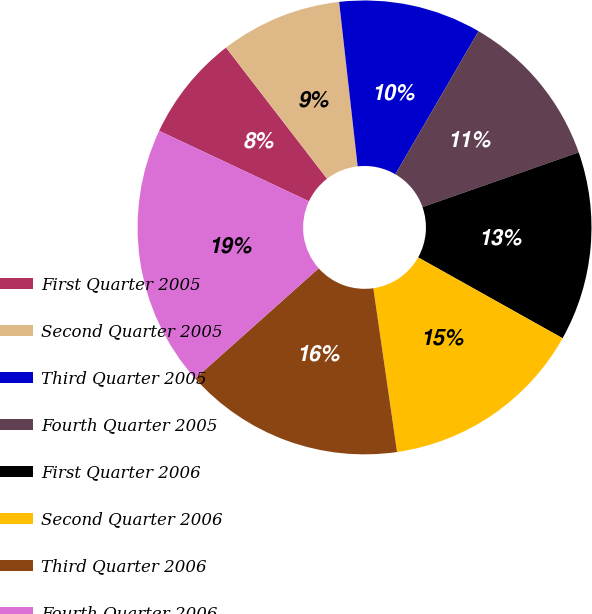<chart> <loc_0><loc_0><loc_500><loc_500><pie_chart><fcel>First Quarter 2005<fcel>Second Quarter 2005<fcel>Third Quarter 2005<fcel>Fourth Quarter 2005<fcel>First Quarter 2006<fcel>Second Quarter 2006<fcel>Third Quarter 2006<fcel>Fourth Quarter 2006<nl><fcel>7.56%<fcel>8.66%<fcel>10.16%<fcel>11.26%<fcel>13.48%<fcel>14.59%<fcel>15.69%<fcel>18.59%<nl></chart> 